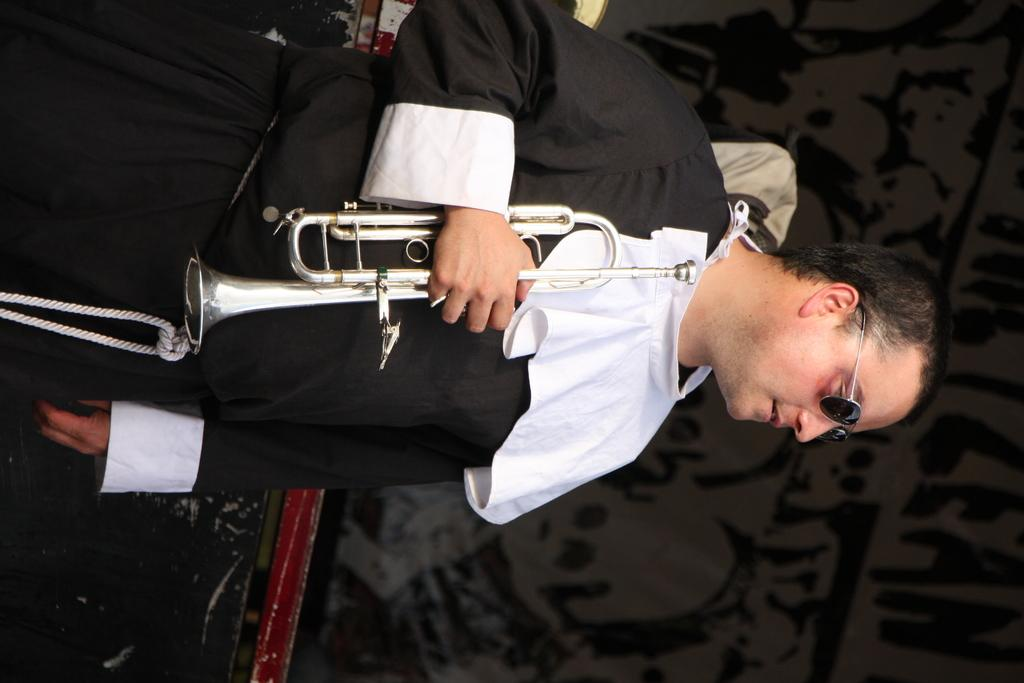What can be seen in the image? There is a person in the image. What is the person wearing? The person is wearing a black dress. What is the person holding? The person is holding a musical instrument. What is the color of the background in the image? The background of the image is dark. How far away is the holiday destination from the person in the image? There is no holiday destination or distance mentioned in the image, as it only features a person holding a musical instrument against a dark background. 